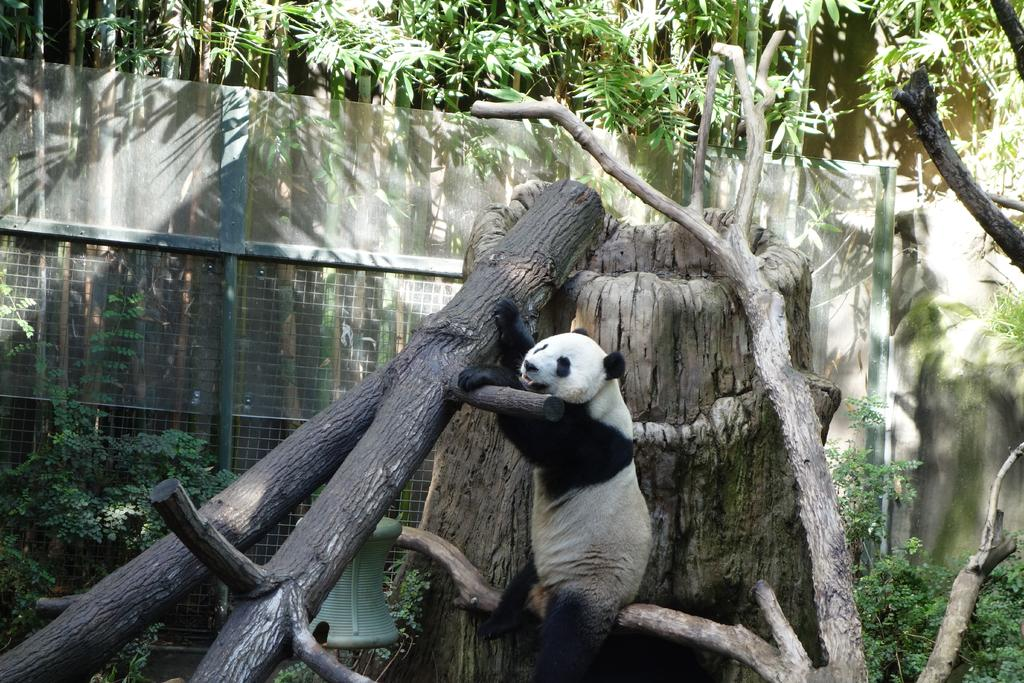What animal is in the middle of the image? There is a panda in the middle of the image. What can be seen in the background of the image? There are trees in the background of the image. What object is visible in the image? There is a net visible in the image. How many girls are present in the image? There are no girls present in the image; it features a panda and trees in the background. What historical event is depicted in the image? There is no historical event depicted in the image; it features a panda, trees, and a net. 